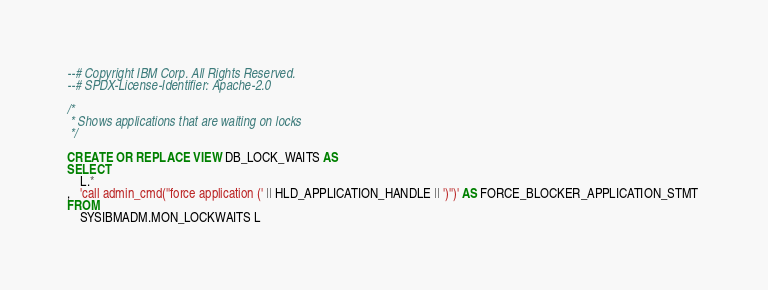Convert code to text. <code><loc_0><loc_0><loc_500><loc_500><_SQL_>--# Copyright IBM Corp. All Rights Reserved.
--# SPDX-License-Identifier: Apache-2.0

/*
 * Shows applications that are waiting on locks
 */

CREATE OR REPLACE VIEW DB_LOCK_WAITS AS
SELECT
    L.*
,   'call admin_cmd(''force application (' || HLD_APPLICATION_HANDLE || ')'')' AS FORCE_BLOCKER_APPLICATION_STMT 
FROM
    SYSIBMADM.MON_LOCKWAITS L</code> 